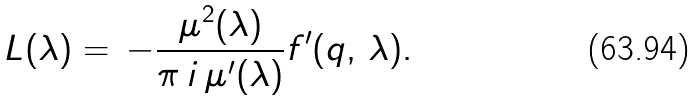<formula> <loc_0><loc_0><loc_500><loc_500>L ( \lambda ) = \, - \frac { \mu ^ { 2 } ( \lambda ) } { \pi \, i \, \mu ^ { \prime } ( \lambda ) } f ^ { \prime } ( q , \, \lambda ) .</formula> 